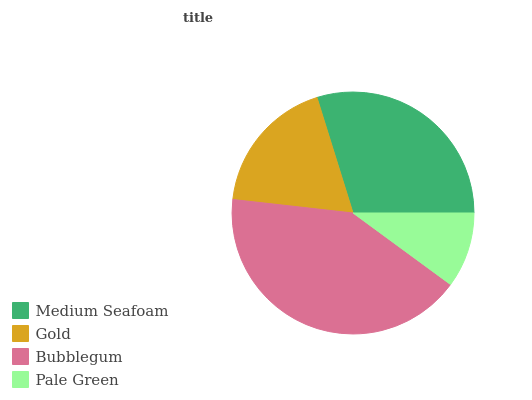Is Pale Green the minimum?
Answer yes or no. Yes. Is Bubblegum the maximum?
Answer yes or no. Yes. Is Gold the minimum?
Answer yes or no. No. Is Gold the maximum?
Answer yes or no. No. Is Medium Seafoam greater than Gold?
Answer yes or no. Yes. Is Gold less than Medium Seafoam?
Answer yes or no. Yes. Is Gold greater than Medium Seafoam?
Answer yes or no. No. Is Medium Seafoam less than Gold?
Answer yes or no. No. Is Medium Seafoam the high median?
Answer yes or no. Yes. Is Gold the low median?
Answer yes or no. Yes. Is Pale Green the high median?
Answer yes or no. No. Is Pale Green the low median?
Answer yes or no. No. 